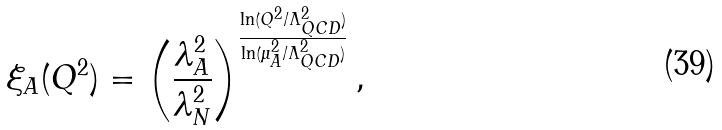Convert formula to latex. <formula><loc_0><loc_0><loc_500><loc_500>\xi _ { A } ( Q ^ { 2 } ) = \left ( \frac { \lambda _ { A } ^ { 2 } } { \lambda _ { N } ^ { 2 } } \right ) ^ { \frac { \ln ( Q ^ { 2 } / \Lambda _ { Q C D } ^ { 2 } ) } { \ln ( \mu _ { A } ^ { 2 } / \Lambda _ { Q C D } ^ { 2 } ) } } ,</formula> 